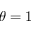Convert formula to latex. <formula><loc_0><loc_0><loc_500><loc_500>\theta = 1</formula> 